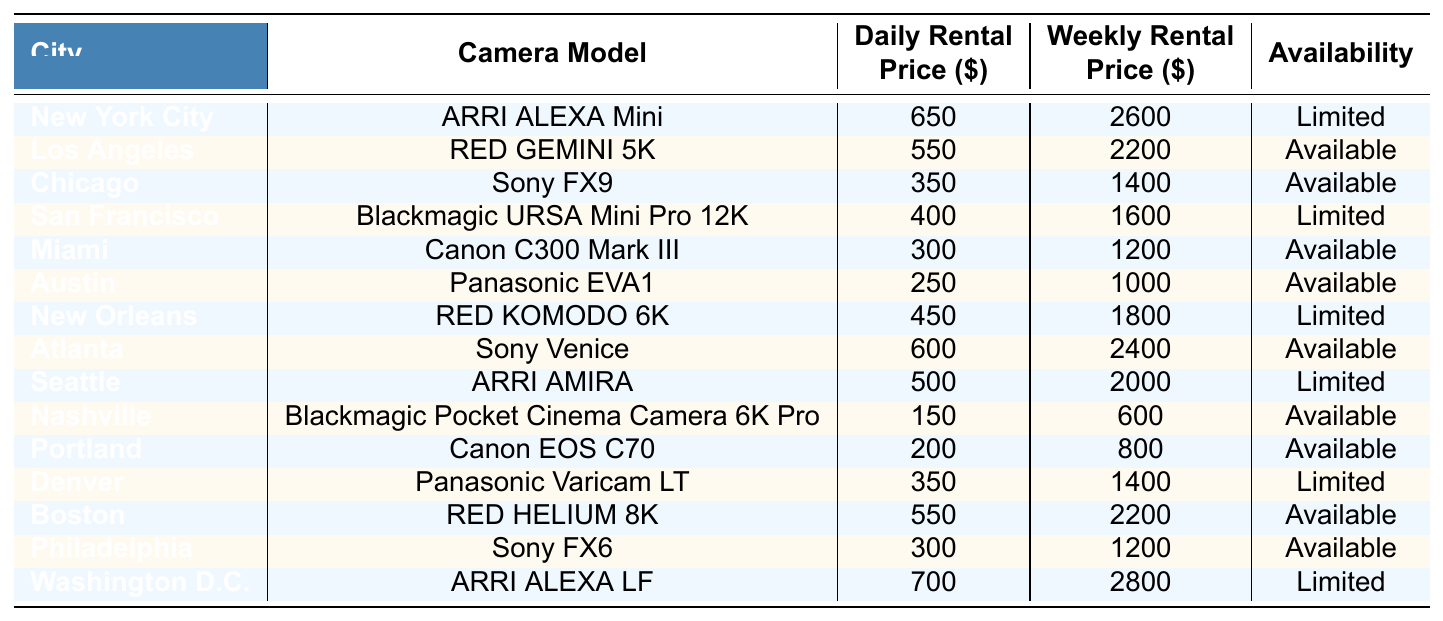What is the daily rental price of the ARRI ALEXA Mini in New York City? The table shows that the daily rental price for the ARRI ALEXA Mini in New York City is $650.
Answer: 650 Which city has the lowest weekly rental price for camera equipment? Reviewing the weekly rental prices, the lowest price is $600 for the Blackmagic Pocket Cinema Camera 6K Pro in Nashville.
Answer: Nashville Is the RED HELIUM 8K available for rent in Boston? According to the table, the RED HELIUM 8K is shown as available for rent in Boston.
Answer: Yes What is the difference between the daily rental price of the Sony FX9 in Chicago and the Canon C300 Mark III in Miami? The daily rental price of the Sony FX9 is $350, and the Canon C300 Mark III is $300. The difference is $350 - $300 = $50.
Answer: 50 How many cities listed have a camera model with a daily rental price below $300? The cities with cameras priced below $300 are Austin ($250), Nashville ($150), and Portland ($200), totaling 3 cities.
Answer: 3 What is the weekly rental price for the ARRI ALEXA LF in Washington D.C.? The table indicates that the weekly rental price for the ARRI ALEXA LF in Washington D.C. is $2800.
Answer: 2800 Which camera model has the highest daily rental price and in which city is it located? The highest daily rental price is $700 for the ARRI ALEXA LF located in Washington D.C.
Answer: Washington D.C If you wanted to rent the Sony FX6 for a week and the Panasonic EVA1 for two days, how much would that cost in total? The weekly rental price for the Sony FX6 is $1200, and the daily rental price for the Panasonic EVA1 is $250 for two days, which totals $500. Therefore, the total cost is $1200 + $500 = $1700.
Answer: 1700 Are there any camera models available for rent in cities with limited availability? Yes, there are several instances of limited availability in the table, such as ARRI ALEXA Mini in New York City, Blackmagic URSA Mini Pro 12K in San Francisco, and others.
Answer: Yes What is the average daily rental price for all the camera models listed? To calculate the average, I sum all daily rental prices: (650 + 550 + 350 + 400 + 300 + 250 + 450 + 600 + 500 + 150 + 200 + 350 + 550 + 300 + 700) = 7,700. There are 15 prices, making the average $7,700 / 15 ≈ $513.33.
Answer: 513.33 